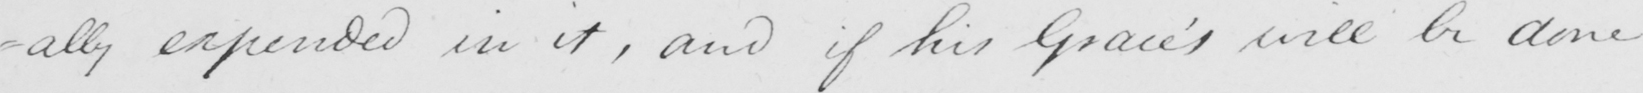Please provide the text content of this handwritten line. -ally expended in it , and if his Grace ' s will be done 